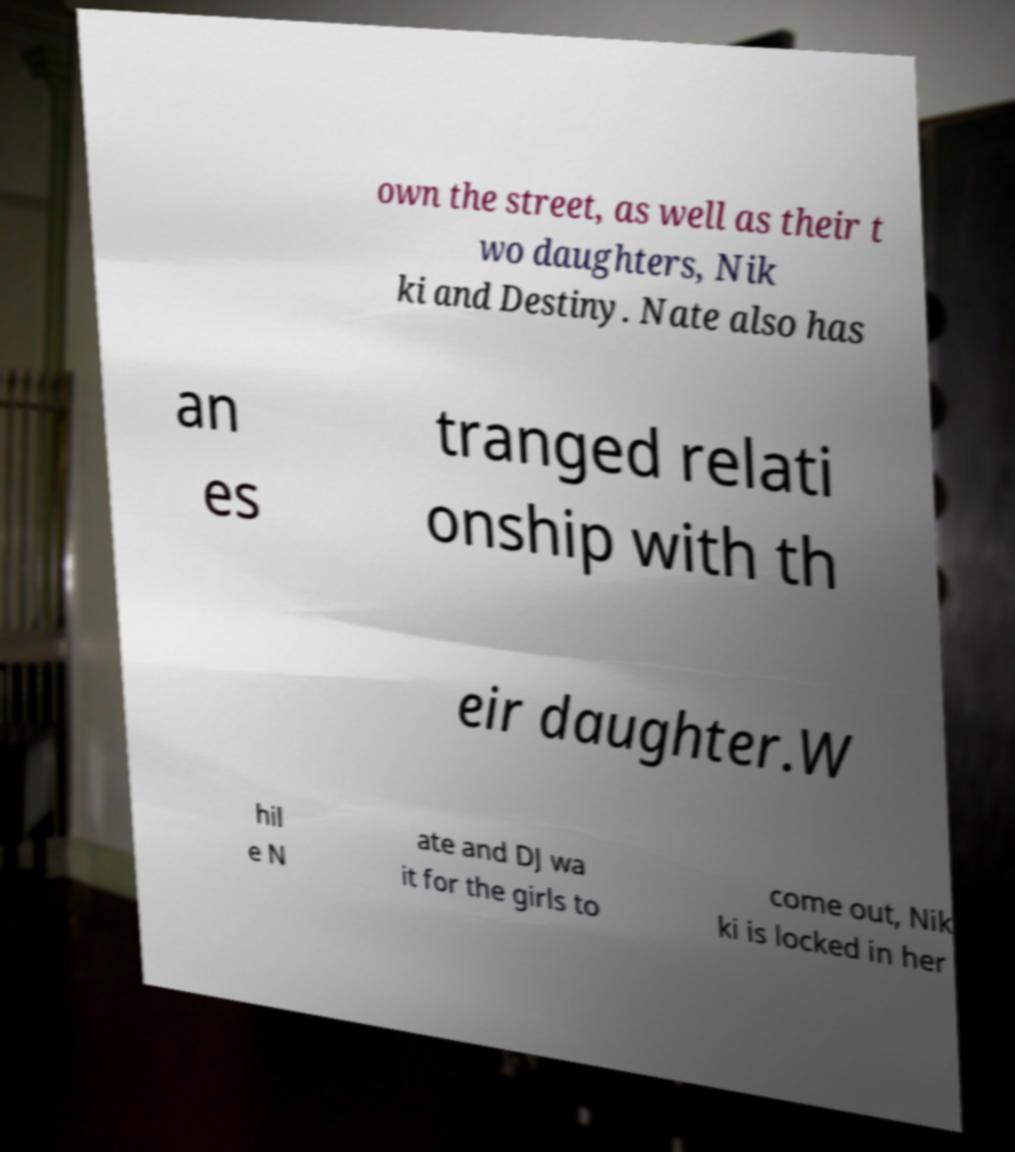Can you read and provide the text displayed in the image?This photo seems to have some interesting text. Can you extract and type it out for me? own the street, as well as their t wo daughters, Nik ki and Destiny. Nate also has an es tranged relati onship with th eir daughter.W hil e N ate and DJ wa it for the girls to come out, Nik ki is locked in her 